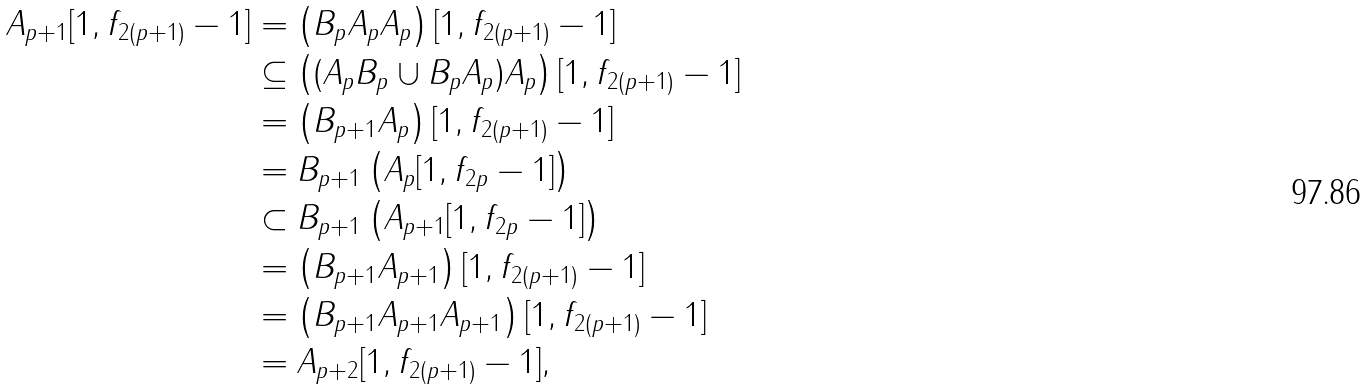Convert formula to latex. <formula><loc_0><loc_0><loc_500><loc_500>A _ { p + 1 } [ 1 , f _ { 2 ( p + 1 ) } - 1 ] & = \left ( B _ { p } A _ { p } A _ { p } \right ) [ 1 , f _ { 2 ( p + 1 ) } - 1 ] \\ & \subseteq \left ( ( A _ { p } B _ { p } \cup B _ { p } A _ { p } ) A _ { p } \right ) [ 1 , f _ { 2 ( p + 1 ) } - 1 ] \\ & = \left ( B _ { p + 1 } A _ { p } \right ) [ 1 , f _ { 2 ( p + 1 ) } - 1 ] \\ & = B _ { p + 1 } \left ( A _ { p } [ 1 , f _ { 2 p } - 1 ] \right ) \\ & \subset B _ { p + 1 } \left ( A _ { p + 1 } [ 1 , f _ { 2 p } - 1 ] \right ) \\ & = \left ( B _ { p + 1 } A _ { p + 1 } \right ) [ 1 , f _ { 2 ( p + 1 ) } - 1 ] \\ & = \left ( B _ { p + 1 } A _ { p + 1 } A _ { p + 1 } \right ) [ 1 , f _ { 2 ( p + 1 ) } - 1 ] \\ & = A _ { p + 2 } [ 1 , f _ { 2 ( p + 1 ) } - 1 ] ,</formula> 